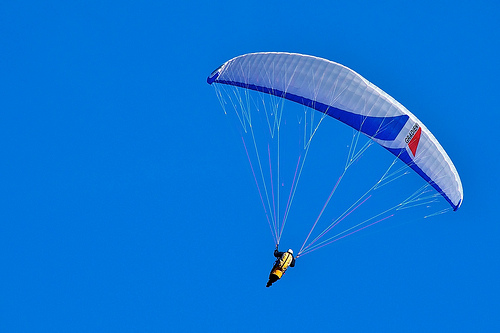Is that a kite or a flag? That is a kite; it is carried by the wind and controlled by the cord held by the person. 